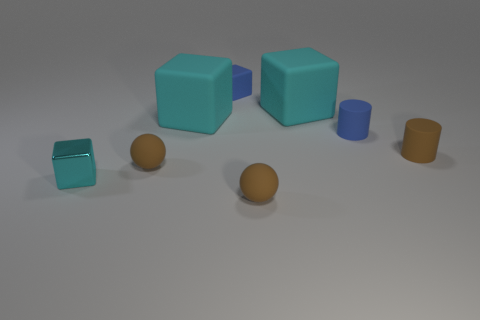Subtract all yellow spheres. How many cyan blocks are left? 3 Add 2 large cyan rubber things. How many objects exist? 10 Subtract all spheres. How many objects are left? 6 Subtract all cyan matte objects. Subtract all blue rubber cubes. How many objects are left? 5 Add 2 cyan rubber things. How many cyan rubber things are left? 4 Add 3 cyan matte things. How many cyan matte things exist? 5 Subtract 0 green spheres. How many objects are left? 8 